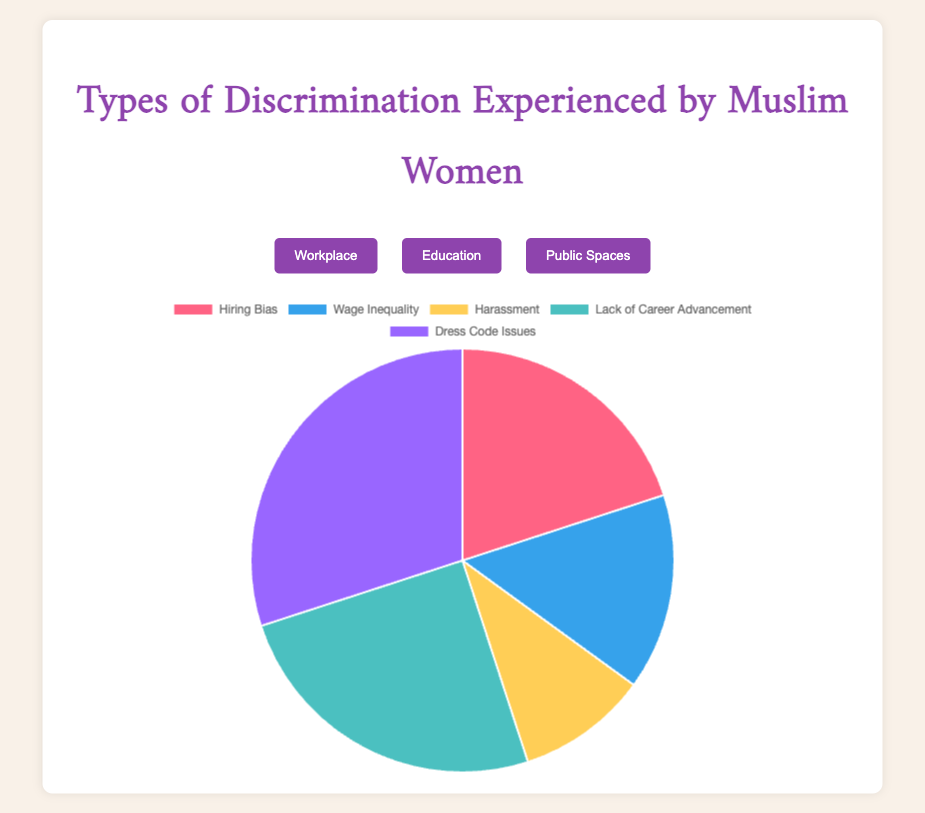What type of discrimination is most common in the workplace? The chart shows five categories of discrimination in the workplace. By visually identifying the largest segment in the pie chart, which represents 30%, we see that "Dress Code Issues" is the most common.
Answer: Dress Code Issues Which category of discrimination in education has the highest percentage? Observing the pie chart for education, we note four categories. The largest segment, representing 40%, is "Bullying by Peers."
Answer: Bullying by Peers Compare the percentages of "Wage Inequality" in the workplace and "Dress Code Policies" in education. In the workplace chart, "Wage Inequality" is 15%. In the education chart, "Dress Code Policies" is also 15%. Both segments appear to be equal in size.
Answer: Equal What is the combined percentage of "Verbal Abuse" and "Physical Harassment" in public spaces? "Verbal Abuse" is 50% and "Physical Harassment" is 20%. Adding these two percentages (50 + 20) gives a total of 70%.
Answer: 70% Which type of discrimination in public spaces has the smallest percentage, and what is that percentage? In the public spaces chart, the smallest segment is "Hate Crimes," representing 5%.
Answer: Hate Crimes, 5% Is the percentage of "Harassment" in the workplace higher or lower than "Discrimination by Teachers" in education? "Harassment" in the workplace is 10%, while "Discrimination by Teachers" in education is 20%. Comparatively, 10% is lower than 20%.
Answer: Lower What percentage of workplace discrimination is related to career advancement, and how does it compare to the percentage of biased curricula in education? "Lack of Career Advancement" in the workplace is 25%. "Biased Curriculum" in education is also 25%. Both segments represent equal percentages.
Answer: Equal Which is greater: the combined percentage of "Verbal Abuse" and "Surveillance and Profiling" in public spaces or "Hiring Bias" and "Wage Inequality" in the workplace? "Verbal Abuse" and "Surveillance and Profiling" in public spaces are 50% and 15%, respectively (50 + 15 = 65%). "Hiring Bias" and "Wage Inequality" in the workplace are 20% and 15% respectively (20 + 15 = 35%). 65% is greater than 35%.
Answer: Public Spaces combination (65%) How does the percentage of "Physical Harassment" in public spaces compare to "Harassment" in the workplace? "Physical Harassment" in public spaces is 20%. "Harassment" in the workplace is 10%. Comparatively, 20% is higher than 10%.
Answer: Higher 